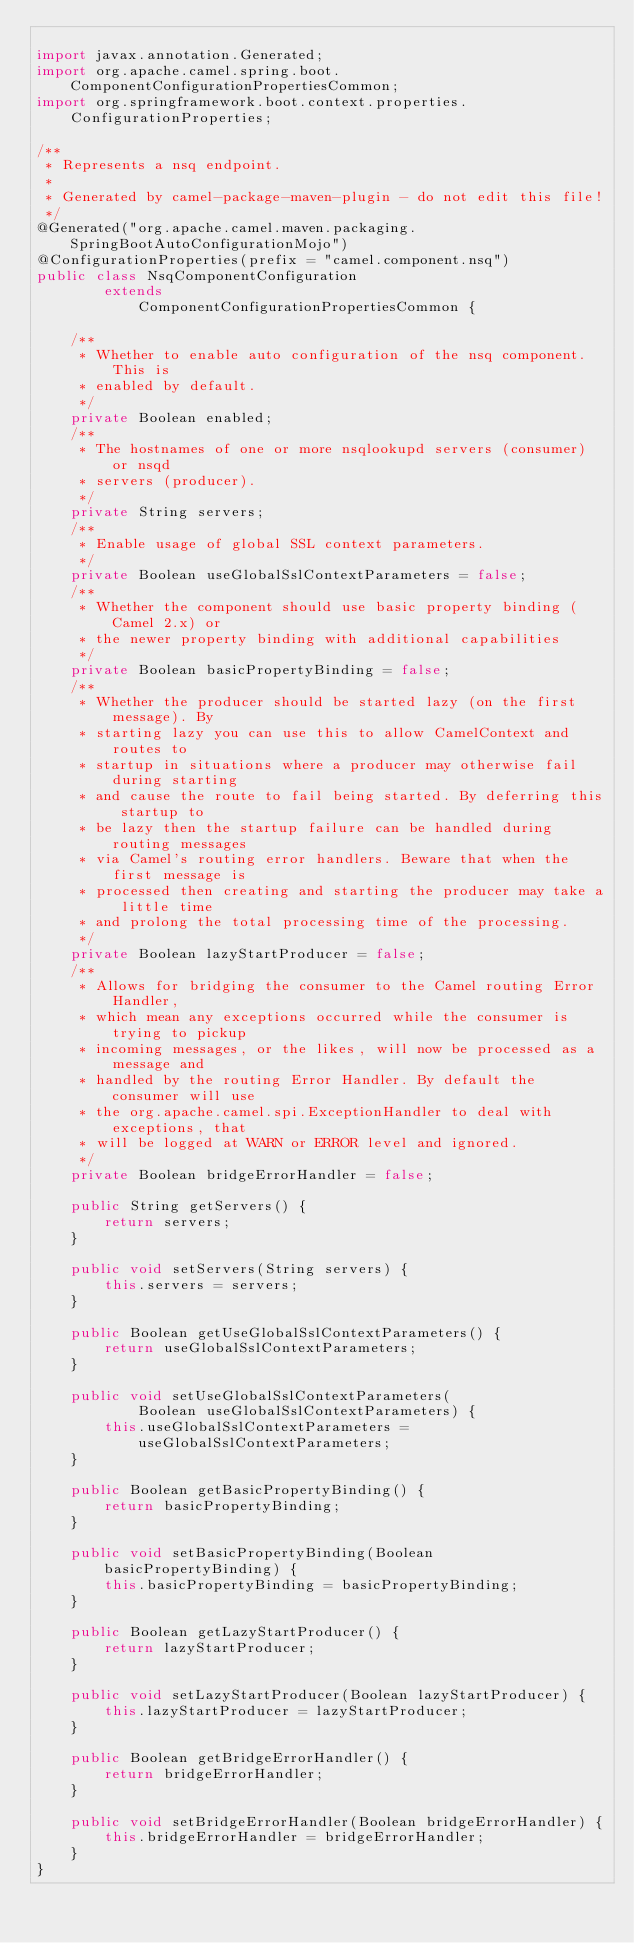<code> <loc_0><loc_0><loc_500><loc_500><_Java_>
import javax.annotation.Generated;
import org.apache.camel.spring.boot.ComponentConfigurationPropertiesCommon;
import org.springframework.boot.context.properties.ConfigurationProperties;

/**
 * Represents a nsq endpoint.
 * 
 * Generated by camel-package-maven-plugin - do not edit this file!
 */
@Generated("org.apache.camel.maven.packaging.SpringBootAutoConfigurationMojo")
@ConfigurationProperties(prefix = "camel.component.nsq")
public class NsqComponentConfiguration
        extends
            ComponentConfigurationPropertiesCommon {

    /**
     * Whether to enable auto configuration of the nsq component. This is
     * enabled by default.
     */
    private Boolean enabled;
    /**
     * The hostnames of one or more nsqlookupd servers (consumer) or nsqd
     * servers (producer).
     */
    private String servers;
    /**
     * Enable usage of global SSL context parameters.
     */
    private Boolean useGlobalSslContextParameters = false;
    /**
     * Whether the component should use basic property binding (Camel 2.x) or
     * the newer property binding with additional capabilities
     */
    private Boolean basicPropertyBinding = false;
    /**
     * Whether the producer should be started lazy (on the first message). By
     * starting lazy you can use this to allow CamelContext and routes to
     * startup in situations where a producer may otherwise fail during starting
     * and cause the route to fail being started. By deferring this startup to
     * be lazy then the startup failure can be handled during routing messages
     * via Camel's routing error handlers. Beware that when the first message is
     * processed then creating and starting the producer may take a little time
     * and prolong the total processing time of the processing.
     */
    private Boolean lazyStartProducer = false;
    /**
     * Allows for bridging the consumer to the Camel routing Error Handler,
     * which mean any exceptions occurred while the consumer is trying to pickup
     * incoming messages, or the likes, will now be processed as a message and
     * handled by the routing Error Handler. By default the consumer will use
     * the org.apache.camel.spi.ExceptionHandler to deal with exceptions, that
     * will be logged at WARN or ERROR level and ignored.
     */
    private Boolean bridgeErrorHandler = false;

    public String getServers() {
        return servers;
    }

    public void setServers(String servers) {
        this.servers = servers;
    }

    public Boolean getUseGlobalSslContextParameters() {
        return useGlobalSslContextParameters;
    }

    public void setUseGlobalSslContextParameters(
            Boolean useGlobalSslContextParameters) {
        this.useGlobalSslContextParameters = useGlobalSslContextParameters;
    }

    public Boolean getBasicPropertyBinding() {
        return basicPropertyBinding;
    }

    public void setBasicPropertyBinding(Boolean basicPropertyBinding) {
        this.basicPropertyBinding = basicPropertyBinding;
    }

    public Boolean getLazyStartProducer() {
        return lazyStartProducer;
    }

    public void setLazyStartProducer(Boolean lazyStartProducer) {
        this.lazyStartProducer = lazyStartProducer;
    }

    public Boolean getBridgeErrorHandler() {
        return bridgeErrorHandler;
    }

    public void setBridgeErrorHandler(Boolean bridgeErrorHandler) {
        this.bridgeErrorHandler = bridgeErrorHandler;
    }
}</code> 